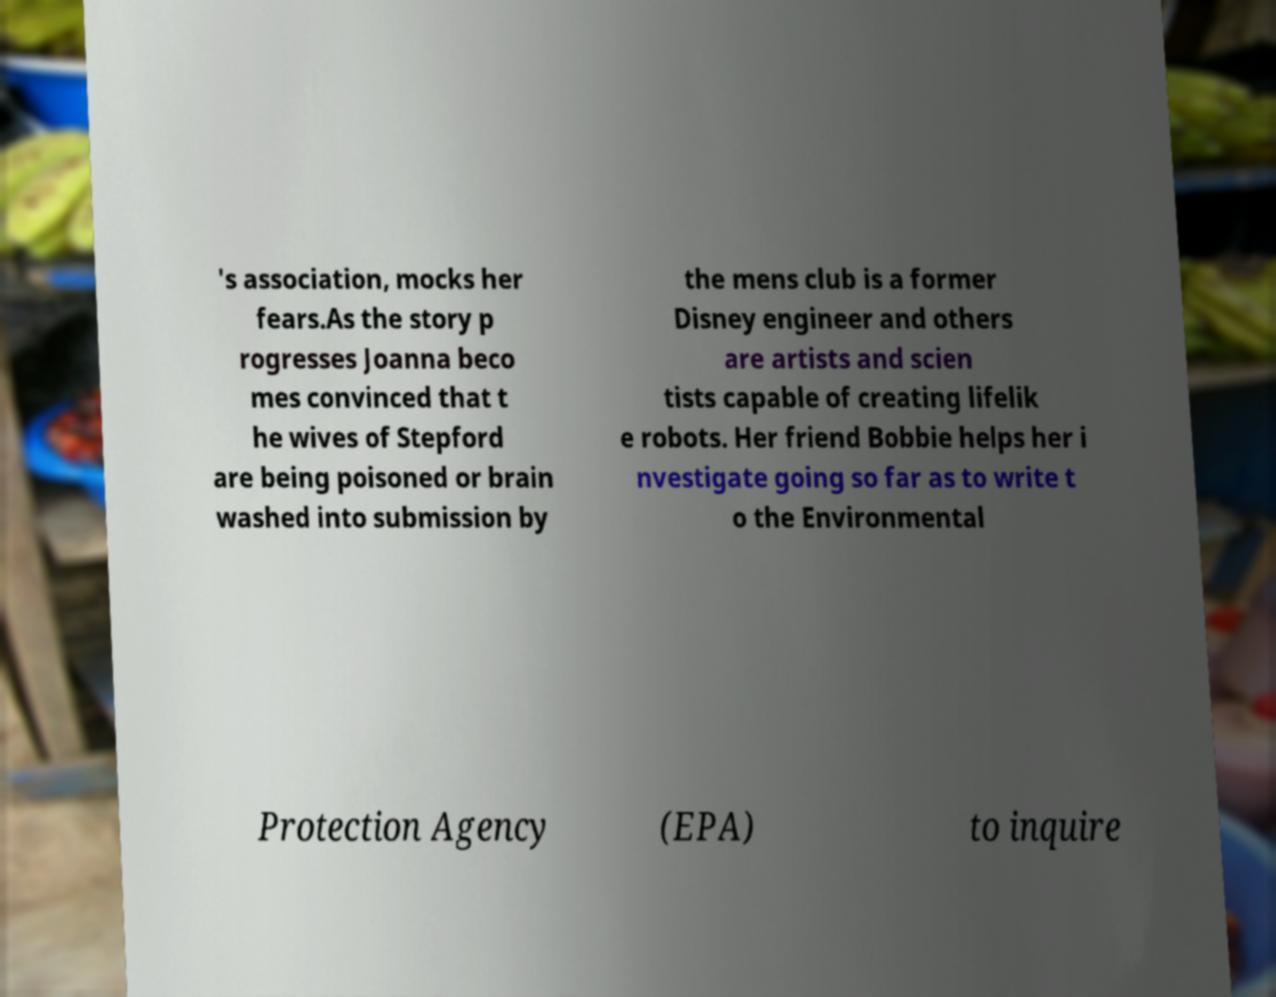Please read and relay the text visible in this image. What does it say? 's association, mocks her fears.As the story p rogresses Joanna beco mes convinced that t he wives of Stepford are being poisoned or brain washed into submission by the mens club is a former Disney engineer and others are artists and scien tists capable of creating lifelik e robots. Her friend Bobbie helps her i nvestigate going so far as to write t o the Environmental Protection Agency (EPA) to inquire 